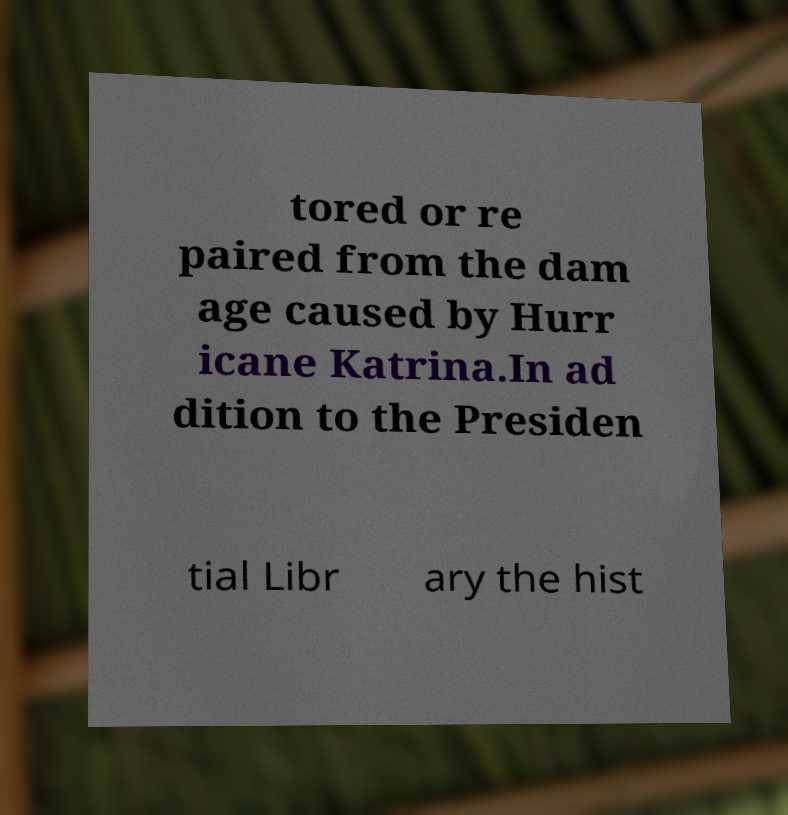Could you extract and type out the text from this image? tored or re paired from the dam age caused by Hurr icane Katrina.In ad dition to the Presiden tial Libr ary the hist 